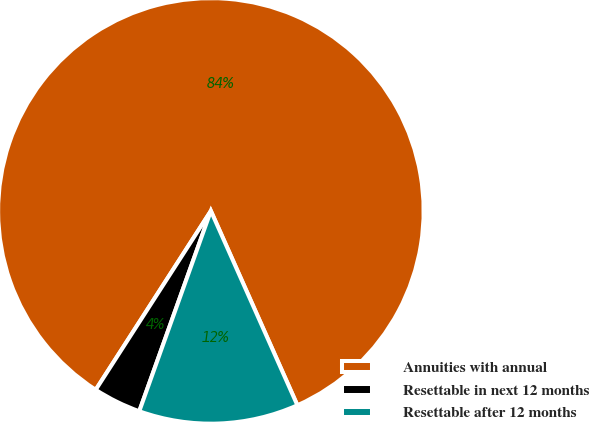<chart> <loc_0><loc_0><loc_500><loc_500><pie_chart><fcel>Annuities with annual<fcel>Resettable in next 12 months<fcel>Resettable after 12 months<nl><fcel>84.24%<fcel>3.64%<fcel>12.13%<nl></chart> 